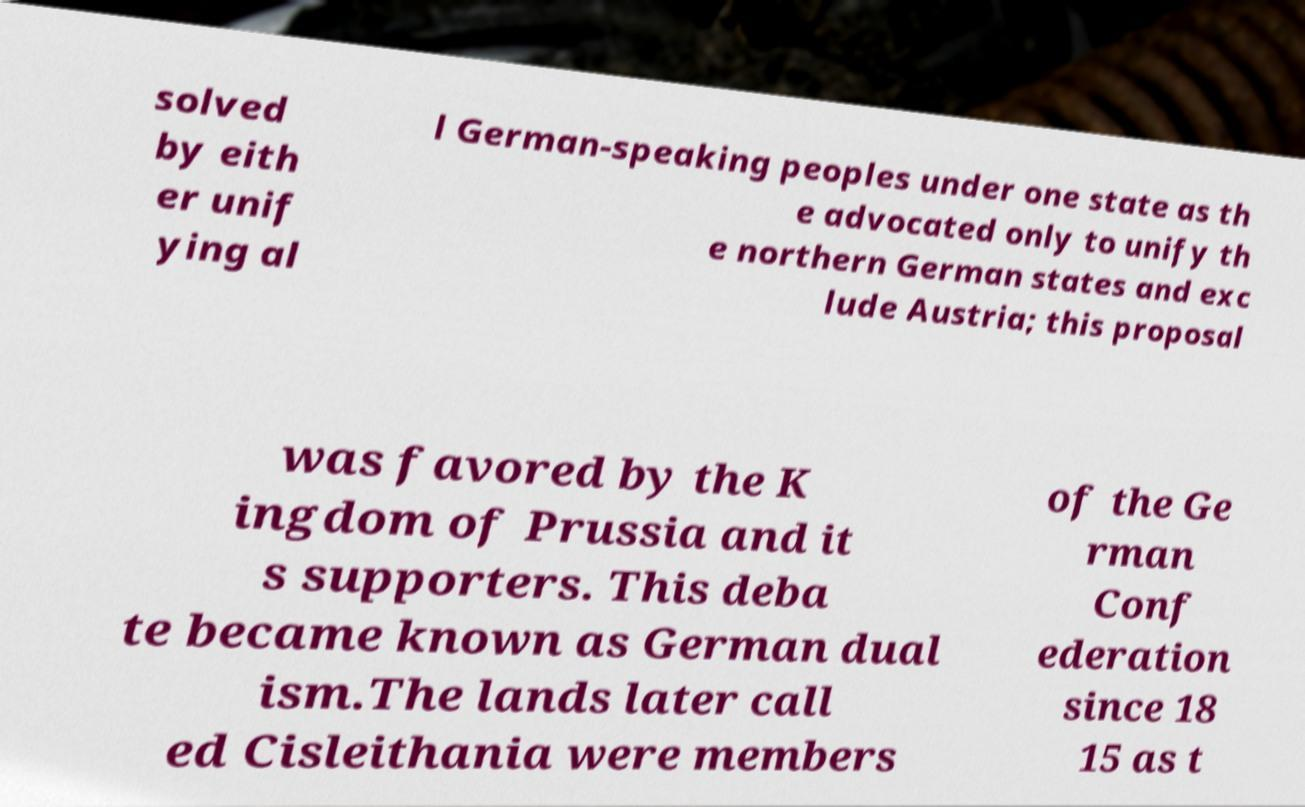Could you assist in decoding the text presented in this image and type it out clearly? solved by eith er unif ying al l German-speaking peoples under one state as th e advocated only to unify th e northern German states and exc lude Austria; this proposal was favored by the K ingdom of Prussia and it s supporters. This deba te became known as German dual ism.The lands later call ed Cisleithania were members of the Ge rman Conf ederation since 18 15 as t 